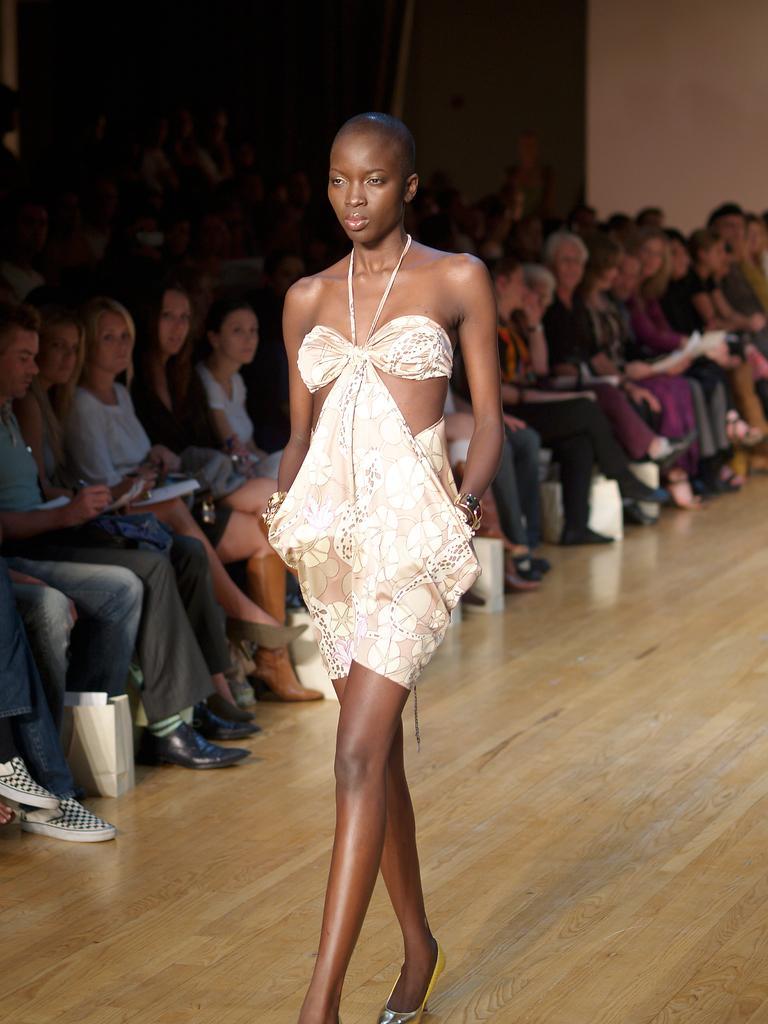In one or two sentences, can you explain what this image depicts? There is a lady walking on the wooden surface. There are many people sitting. On the left side there is a packet on the floor. 